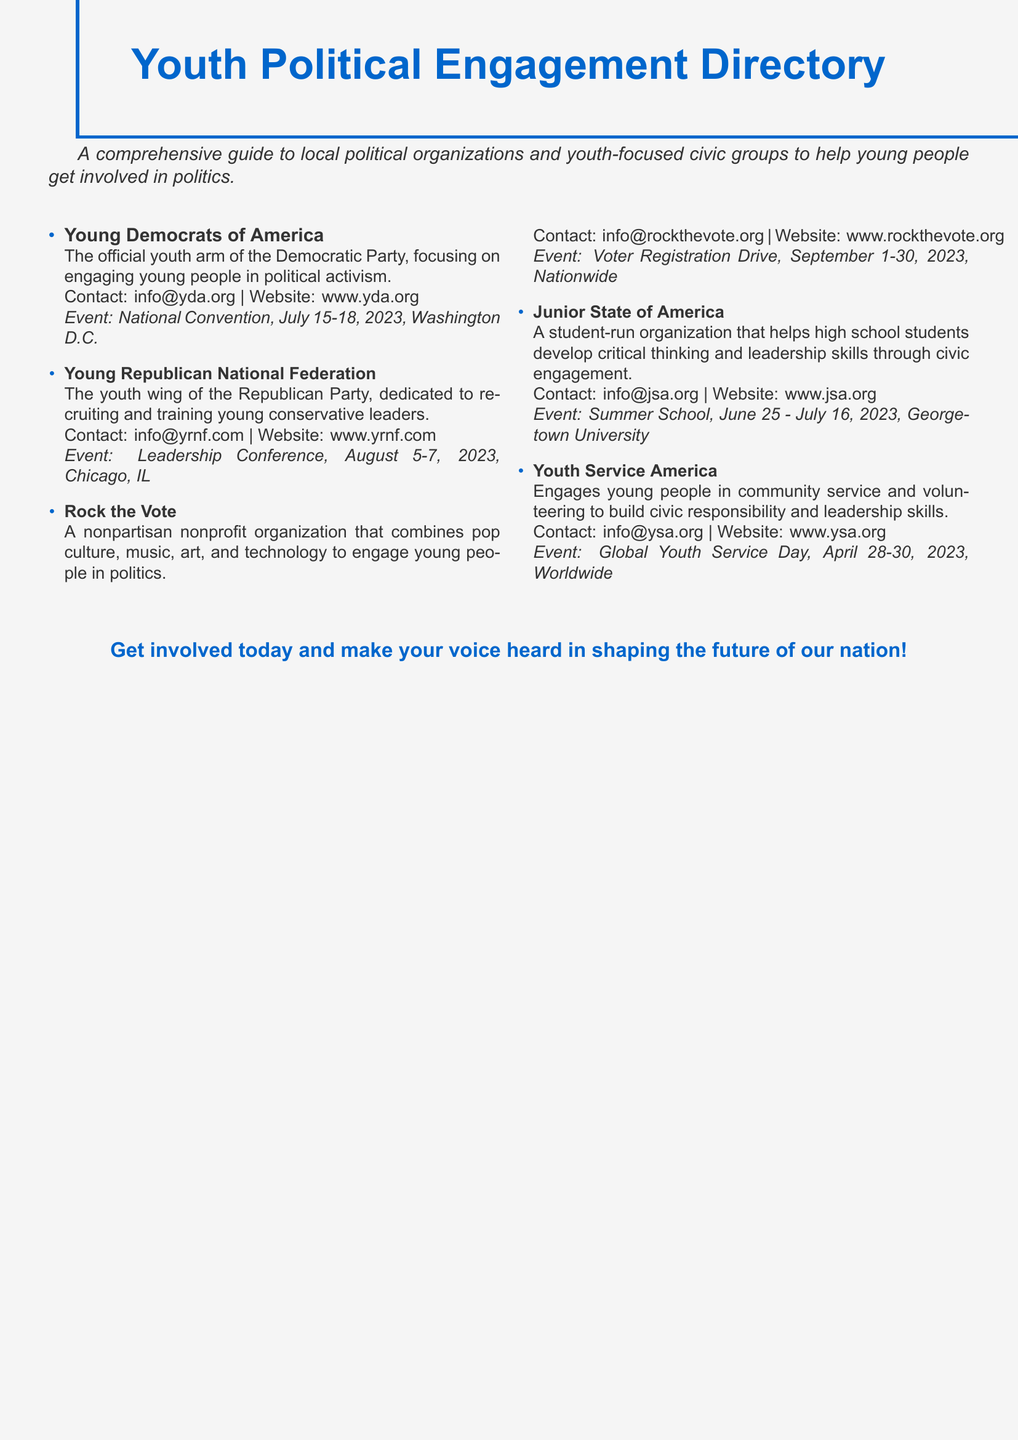what is the name of the official youth arm of the Democratic Party? The document states that the name of the official youth arm of the Democratic Party is the Young Democrats of America.
Answer: Young Democrats of America what is the event date for the National Convention? The National Convention is scheduled to take place from July 15-18, 2023, as mentioned in the document.
Answer: July 15-18, 2023 which organization focuses on engaging young people in politics through pop culture? The document indicates that Rock the Vote focuses on engaging young people in politics through pop culture.
Answer: Rock the Vote how many organizations are listed in the directory? The document lists a total of five political organizations and youth-focused civic groups.
Answer: 5 what is the contact email for the Young Republican National Federation? The document provides the contact email for the Young Republican National Federation as info@yrnf.com.
Answer: info@yrnf.com which event occurs in April 2023? The Global Youth Service Day is the event mentioned that occurs in April 2023, specifically from April 28-30.
Answer: Global Youth Service Day what common goal do the organizations in this directory share? The organizations in the directory share the common goal of engaging young people in political activism and civic engagement.
Answer: Engaging young people in political activism where is the Summer School event hosted by the Junior State of America? The document states that the Summer School event is hosted at Georgetown University.
Answer: Georgetown University 